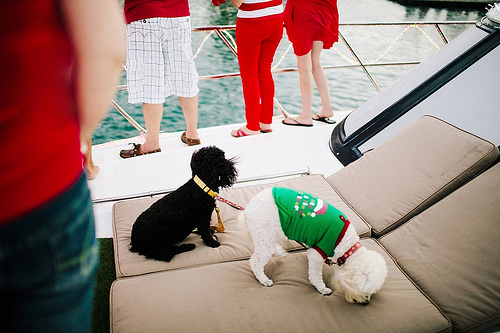<image>
Is there a sofa under the dog? Yes. The sofa is positioned underneath the dog, with the dog above it in the vertical space. Where is the person in relation to the dog? Is it in front of the dog? No. The person is not in front of the dog. The spatial positioning shows a different relationship between these objects. 